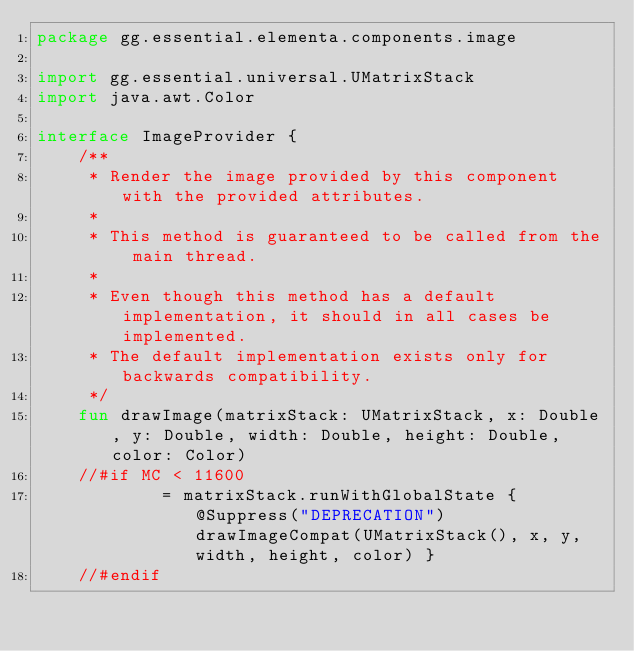Convert code to text. <code><loc_0><loc_0><loc_500><loc_500><_Kotlin_>package gg.essential.elementa.components.image

import gg.essential.universal.UMatrixStack
import java.awt.Color

interface ImageProvider {
    /**
     * Render the image provided by this component with the provided attributes.
     *
     * This method is guaranteed to be called from the main thread.
     *
     * Even though this method has a default implementation, it should in all cases be implemented.
     * The default implementation exists only for backwards compatibility.
     */
    fun drawImage(matrixStack: UMatrixStack, x: Double, y: Double, width: Double, height: Double, color: Color)
    //#if MC < 11600
            = matrixStack.runWithGlobalState { @Suppress("DEPRECATION") drawImageCompat(UMatrixStack(), x, y, width, height, color) }
    //#endif
</code> 